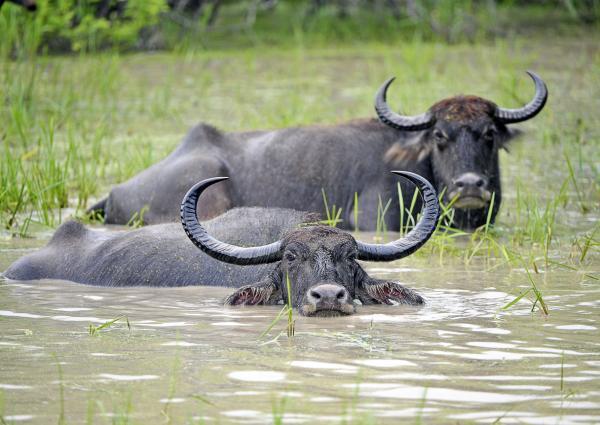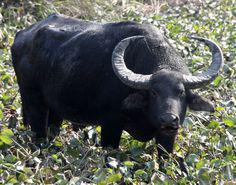The first image is the image on the left, the second image is the image on the right. Given the left and right images, does the statement "There are exactly two water buffalo in the left image." hold true? Answer yes or no. Yes. The first image is the image on the left, the second image is the image on the right. For the images shown, is this caption "The left image shows one adult in a hat holding a stick behind a team of two hitched oxen walking in a wet area." true? Answer yes or no. No. 